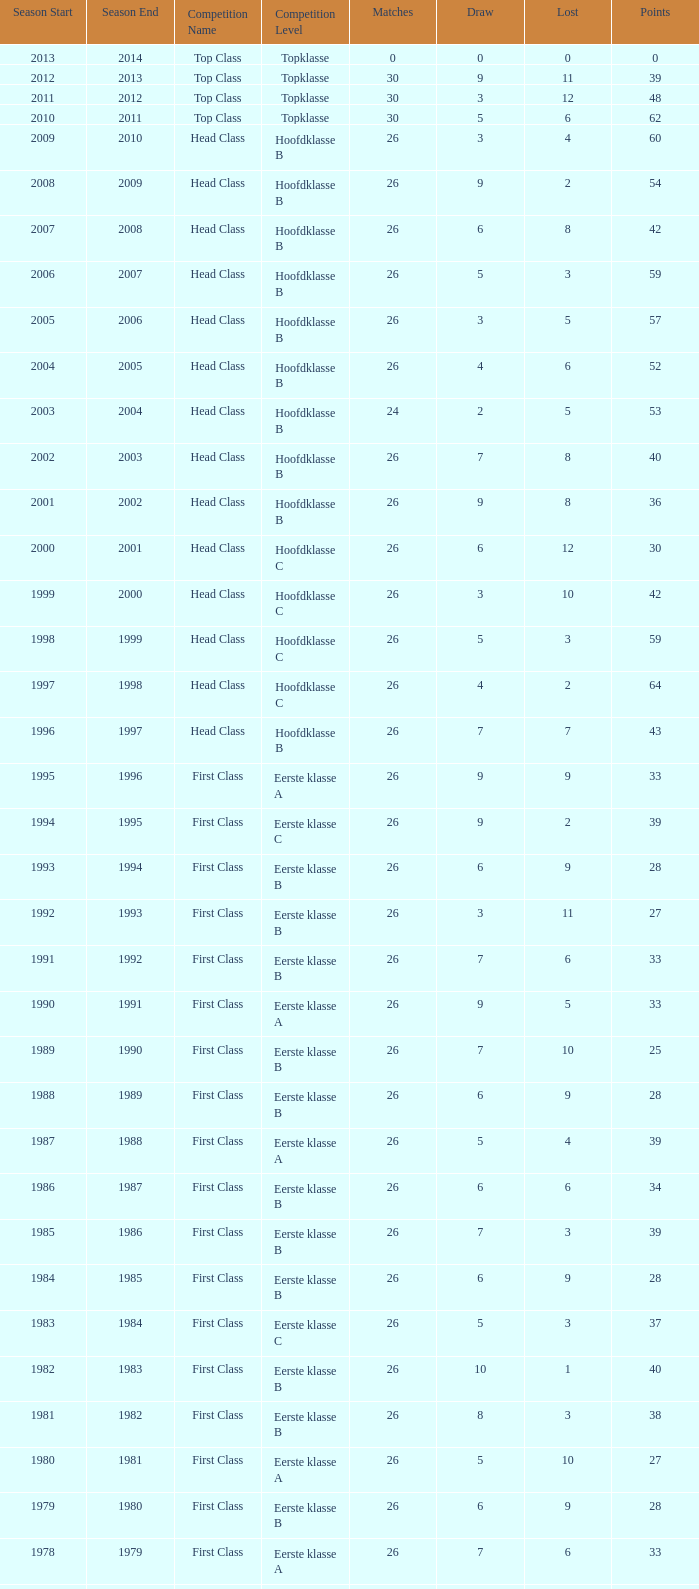What is the sum of the losses that a match score larger than 26, a points score of 62, and a draw greater than 5? None. 